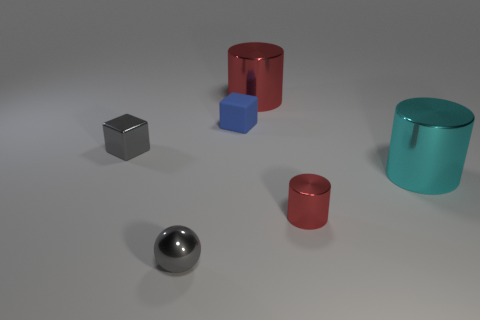What objects can you identify in the image? In the image, you can see a collection of six objects in total, which includes a gray cube, a blue cube, a red cylinder, a red cup, a teal cylinder, and a sphere that appears to be metallic. 